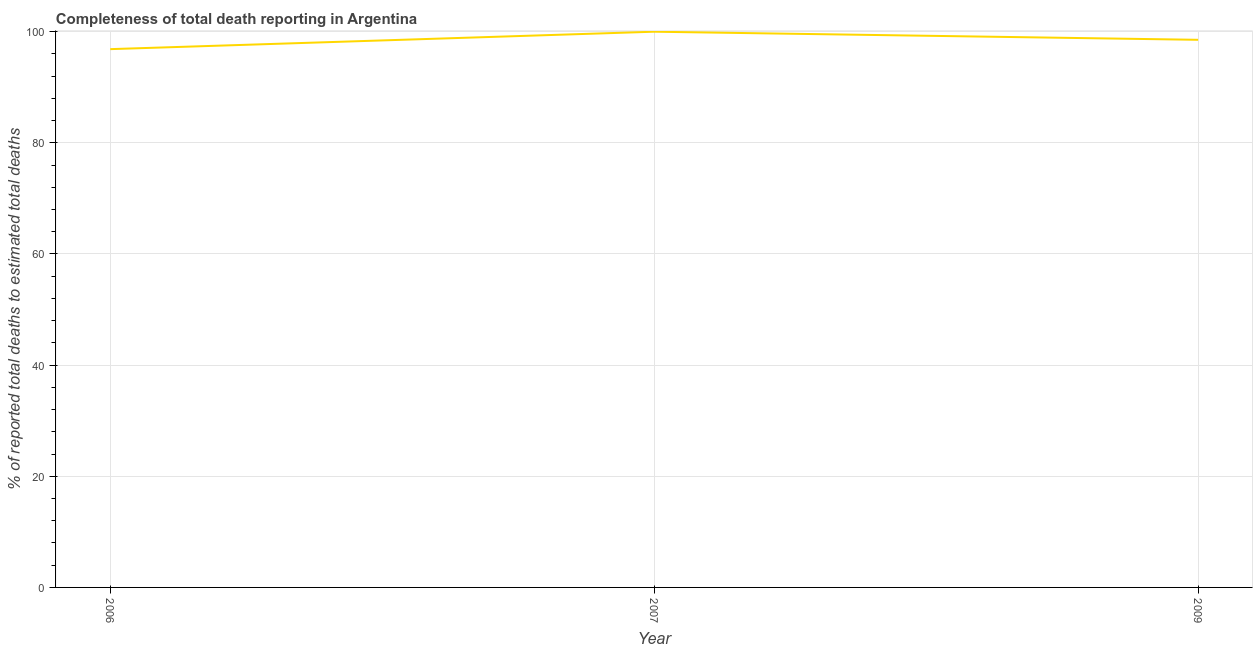What is the completeness of total death reports in 2009?
Make the answer very short. 98.54. Across all years, what is the maximum completeness of total death reports?
Give a very brief answer. 100. Across all years, what is the minimum completeness of total death reports?
Offer a terse response. 96.86. In which year was the completeness of total death reports maximum?
Offer a terse response. 2007. In which year was the completeness of total death reports minimum?
Your answer should be compact. 2006. What is the sum of the completeness of total death reports?
Offer a terse response. 295.4. What is the difference between the completeness of total death reports in 2006 and 2009?
Give a very brief answer. -1.68. What is the average completeness of total death reports per year?
Offer a terse response. 98.47. What is the median completeness of total death reports?
Offer a terse response. 98.54. What is the ratio of the completeness of total death reports in 2007 to that in 2009?
Make the answer very short. 1.01. Is the completeness of total death reports in 2006 less than that in 2009?
Offer a very short reply. Yes. Is the difference between the completeness of total death reports in 2006 and 2007 greater than the difference between any two years?
Your response must be concise. Yes. What is the difference between the highest and the second highest completeness of total death reports?
Keep it short and to the point. 1.46. Is the sum of the completeness of total death reports in 2006 and 2009 greater than the maximum completeness of total death reports across all years?
Provide a short and direct response. Yes. What is the difference between the highest and the lowest completeness of total death reports?
Give a very brief answer. 3.14. Does the completeness of total death reports monotonically increase over the years?
Make the answer very short. No. Are the values on the major ticks of Y-axis written in scientific E-notation?
Give a very brief answer. No. Does the graph contain any zero values?
Give a very brief answer. No. Does the graph contain grids?
Your response must be concise. Yes. What is the title of the graph?
Provide a succinct answer. Completeness of total death reporting in Argentina. What is the label or title of the X-axis?
Ensure brevity in your answer.  Year. What is the label or title of the Y-axis?
Ensure brevity in your answer.  % of reported total deaths to estimated total deaths. What is the % of reported total deaths to estimated total deaths of 2006?
Provide a short and direct response. 96.86. What is the % of reported total deaths to estimated total deaths of 2007?
Make the answer very short. 100. What is the % of reported total deaths to estimated total deaths of 2009?
Provide a short and direct response. 98.54. What is the difference between the % of reported total deaths to estimated total deaths in 2006 and 2007?
Offer a terse response. -3.14. What is the difference between the % of reported total deaths to estimated total deaths in 2006 and 2009?
Keep it short and to the point. -1.68. What is the difference between the % of reported total deaths to estimated total deaths in 2007 and 2009?
Your answer should be compact. 1.46. What is the ratio of the % of reported total deaths to estimated total deaths in 2007 to that in 2009?
Offer a terse response. 1.01. 